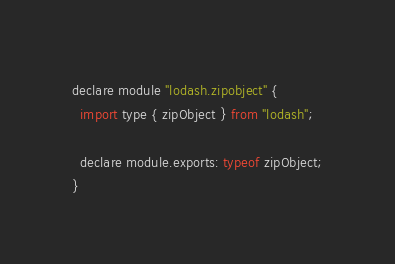<code> <loc_0><loc_0><loc_500><loc_500><_JavaScript_>declare module "lodash.zipobject" {
  import type { zipObject } from "lodash";

  declare module.exports: typeof zipObject;
}
</code> 